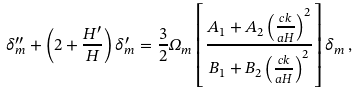<formula> <loc_0><loc_0><loc_500><loc_500>\delta ^ { \prime \prime } _ { m } + \left ( 2 + \frac { H ^ { \prime } } { H } \right ) \delta ^ { \prime } _ { m } = \frac { 3 } { 2 } \Omega _ { m } \left [ \frac { A _ { 1 } + A _ { 2 } \left ( \frac { c k } { a H } \right ) ^ { 2 } } { B _ { 1 } + B _ { 2 } \left ( \frac { c k } { a H } \right ) ^ { 2 } } \right ] \delta _ { m } \, ,</formula> 